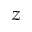<formula> <loc_0><loc_0><loc_500><loc_500>z</formula> 